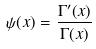<formula> <loc_0><loc_0><loc_500><loc_500>\psi ( x ) = \frac { \Gamma ^ { \prime } ( x ) } { \Gamma ( x ) }</formula> 